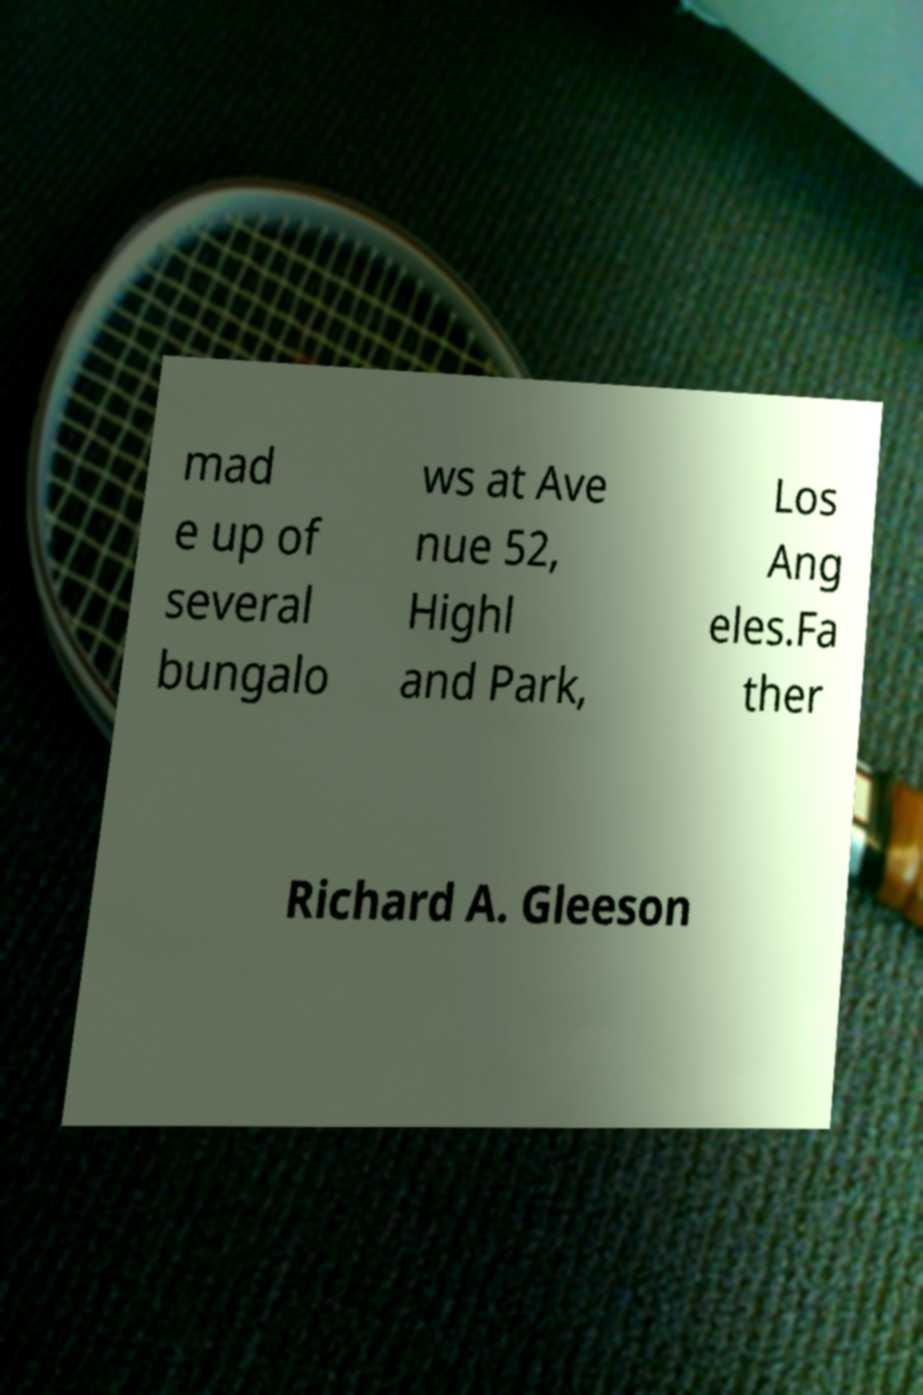Please read and relay the text visible in this image. What does it say? mad e up of several bungalo ws at Ave nue 52, Highl and Park, Los Ang eles.Fa ther Richard A. Gleeson 